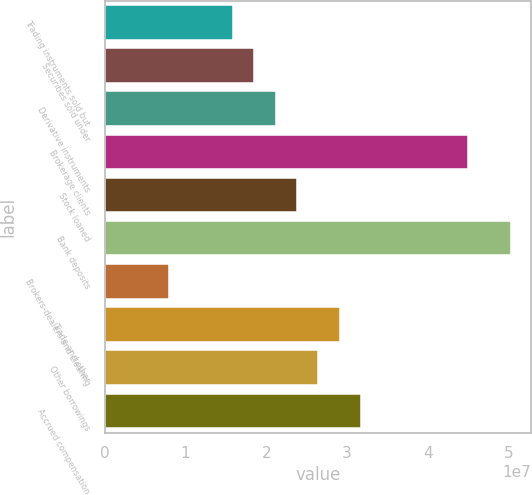Convert chart. <chart><loc_0><loc_0><loc_500><loc_500><bar_chart><fcel>Trading instruments sold but<fcel>Securities sold under<fcel>Derivative instruments<fcel>Brokerage clients<fcel>Stock loaned<fcel>Bank deposits<fcel>Brokers-dealers and clearing<fcel>Trade and other<fcel>Other borrowings<fcel>Accrued compensation<nl><fcel>1.58814e+07<fcel>1.85281e+07<fcel>2.11747e+07<fcel>4.49946e+07<fcel>2.38214e+07<fcel>5.02879e+07<fcel>7.94145e+06<fcel>2.91147e+07<fcel>2.6468e+07<fcel>3.17613e+07<nl></chart> 